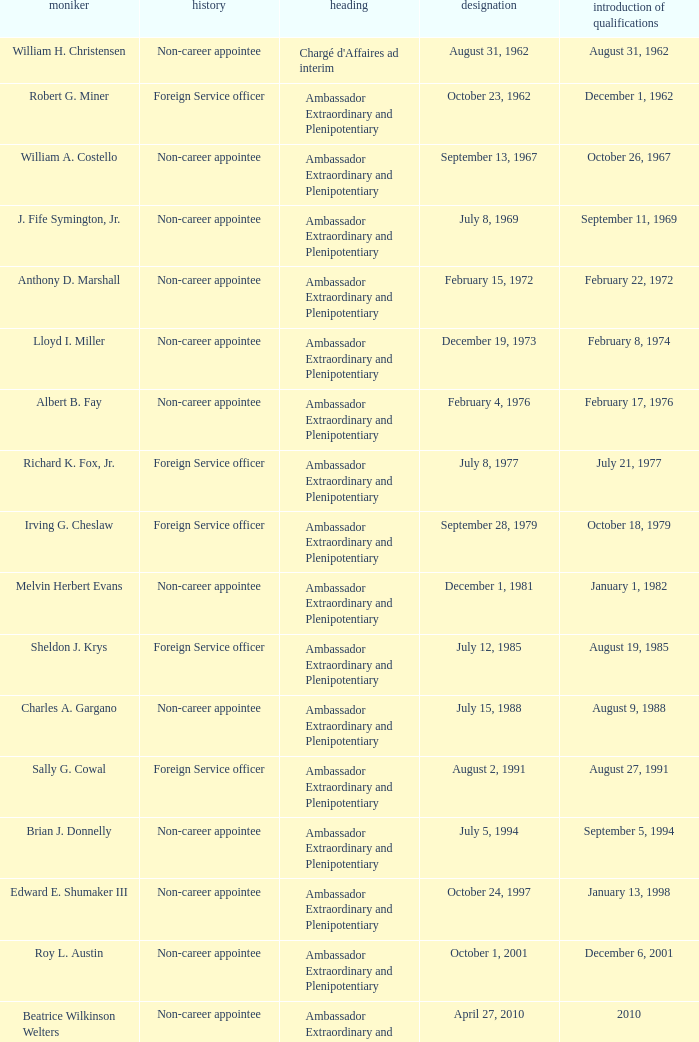When was William A. Costello appointed? September 13, 1967. 